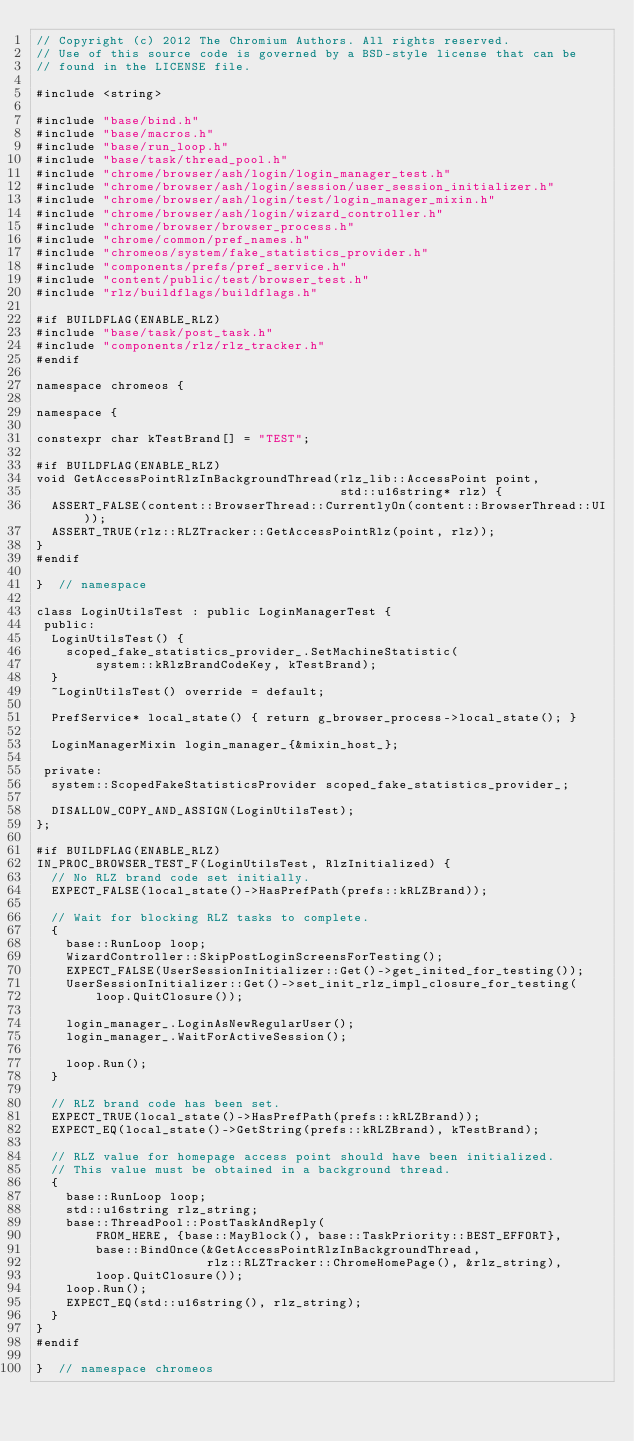Convert code to text. <code><loc_0><loc_0><loc_500><loc_500><_C++_>// Copyright (c) 2012 The Chromium Authors. All rights reserved.
// Use of this source code is governed by a BSD-style license that can be
// found in the LICENSE file.

#include <string>

#include "base/bind.h"
#include "base/macros.h"
#include "base/run_loop.h"
#include "base/task/thread_pool.h"
#include "chrome/browser/ash/login/login_manager_test.h"
#include "chrome/browser/ash/login/session/user_session_initializer.h"
#include "chrome/browser/ash/login/test/login_manager_mixin.h"
#include "chrome/browser/ash/login/wizard_controller.h"
#include "chrome/browser/browser_process.h"
#include "chrome/common/pref_names.h"
#include "chromeos/system/fake_statistics_provider.h"
#include "components/prefs/pref_service.h"
#include "content/public/test/browser_test.h"
#include "rlz/buildflags/buildflags.h"

#if BUILDFLAG(ENABLE_RLZ)
#include "base/task/post_task.h"
#include "components/rlz/rlz_tracker.h"
#endif

namespace chromeos {

namespace {

constexpr char kTestBrand[] = "TEST";

#if BUILDFLAG(ENABLE_RLZ)
void GetAccessPointRlzInBackgroundThread(rlz_lib::AccessPoint point,
                                         std::u16string* rlz) {
  ASSERT_FALSE(content::BrowserThread::CurrentlyOn(content::BrowserThread::UI));
  ASSERT_TRUE(rlz::RLZTracker::GetAccessPointRlz(point, rlz));
}
#endif

}  // namespace

class LoginUtilsTest : public LoginManagerTest {
 public:
  LoginUtilsTest() {
    scoped_fake_statistics_provider_.SetMachineStatistic(
        system::kRlzBrandCodeKey, kTestBrand);
  }
  ~LoginUtilsTest() override = default;

  PrefService* local_state() { return g_browser_process->local_state(); }

  LoginManagerMixin login_manager_{&mixin_host_};

 private:
  system::ScopedFakeStatisticsProvider scoped_fake_statistics_provider_;

  DISALLOW_COPY_AND_ASSIGN(LoginUtilsTest);
};

#if BUILDFLAG(ENABLE_RLZ)
IN_PROC_BROWSER_TEST_F(LoginUtilsTest, RlzInitialized) {
  // No RLZ brand code set initially.
  EXPECT_FALSE(local_state()->HasPrefPath(prefs::kRLZBrand));

  // Wait for blocking RLZ tasks to complete.
  {
    base::RunLoop loop;
    WizardController::SkipPostLoginScreensForTesting();
    EXPECT_FALSE(UserSessionInitializer::Get()->get_inited_for_testing());
    UserSessionInitializer::Get()->set_init_rlz_impl_closure_for_testing(
        loop.QuitClosure());

    login_manager_.LoginAsNewRegularUser();
    login_manager_.WaitForActiveSession();

    loop.Run();
  }

  // RLZ brand code has been set.
  EXPECT_TRUE(local_state()->HasPrefPath(prefs::kRLZBrand));
  EXPECT_EQ(local_state()->GetString(prefs::kRLZBrand), kTestBrand);

  // RLZ value for homepage access point should have been initialized.
  // This value must be obtained in a background thread.
  {
    base::RunLoop loop;
    std::u16string rlz_string;
    base::ThreadPool::PostTaskAndReply(
        FROM_HERE, {base::MayBlock(), base::TaskPriority::BEST_EFFORT},
        base::BindOnce(&GetAccessPointRlzInBackgroundThread,
                       rlz::RLZTracker::ChromeHomePage(), &rlz_string),
        loop.QuitClosure());
    loop.Run();
    EXPECT_EQ(std::u16string(), rlz_string);
  }
}
#endif

}  // namespace chromeos
</code> 